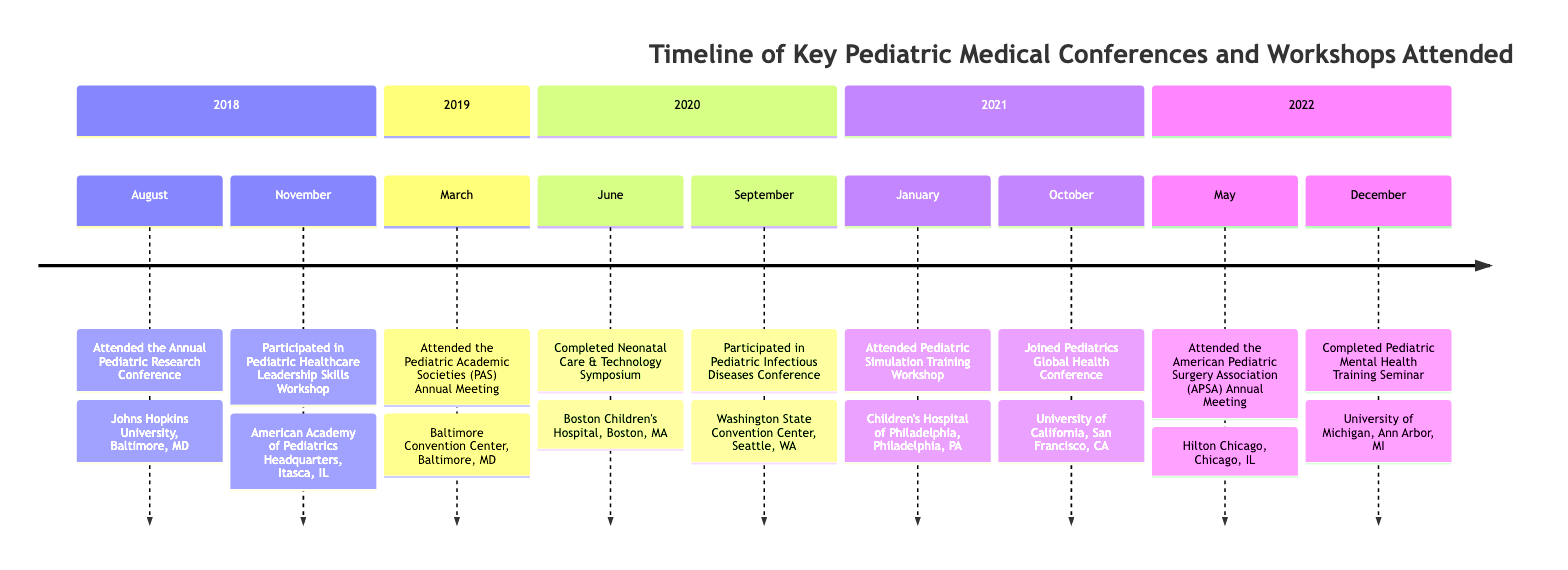What event was attended in August 2018? The timeline shows that the event attended in August 2018 was the Annual Pediatric Research Conference.
Answer: Annual Pediatric Research Conference How many conferences were attended in 2020? By examining the timeline, there are two conferences listed in 2020: the Neonatal Care & Technology Symposium in June and the Pediatric Infectious Diseases Conference in September.
Answer: 2 Which event took place in October 2021? The timeline indicates that the event in October 2021 was the Pediatrics Global Health Conference.
Answer: Pediatrics Global Health Conference What location was the Pediatric Simulation Training Workshop held? Referencing the timeline, the Pediatric Simulation Training Workshop took place at Children's Hospital of Philadelphia, Philadelphia, PA.
Answer: Children's Hospital of Philadelphia, Philadelphia, PA Which event focused on pediatric mental health? According to the timeline, the Pediatric Mental Health Training Seminar in December 2022 focused on pediatric mental health topics.
Answer: Pediatric Mental Health Training Seminar What month did the Pediatric Academic Societies (PAS) Annual Meeting occur? The timeline specifies that the Pediatric Academic Societies (PAS) Annual Meeting occurred in March 2019.
Answer: March How many events were held at Johns Hopkins University? The timeline shows one event held at Johns Hopkins University, which is the Annual Pediatric Research Conference in August 2018.
Answer: 1 What is the primary focus of the conference attended in May 2022? The timeline indicates that the American Pediatric Surgery Association (APSA) Annual Meeting attended in May 2022 primarily focused on advancements in pediatric surgical techniques and patient care.
Answer: Advancements in pediatric surgical techniques and patient care What year was the Pediatric Healthcare Leadership Skills Workshop held? Looking at the timeline, the Pediatric Healthcare Leadership Skills Workshop was held in November 2018.
Answer: 2018 